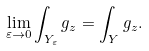Convert formula to latex. <formula><loc_0><loc_0><loc_500><loc_500>\lim _ { \varepsilon \rightarrow 0 } \int _ { Y _ { \varepsilon } } g _ { z } = \int _ { Y } g _ { z } .</formula> 